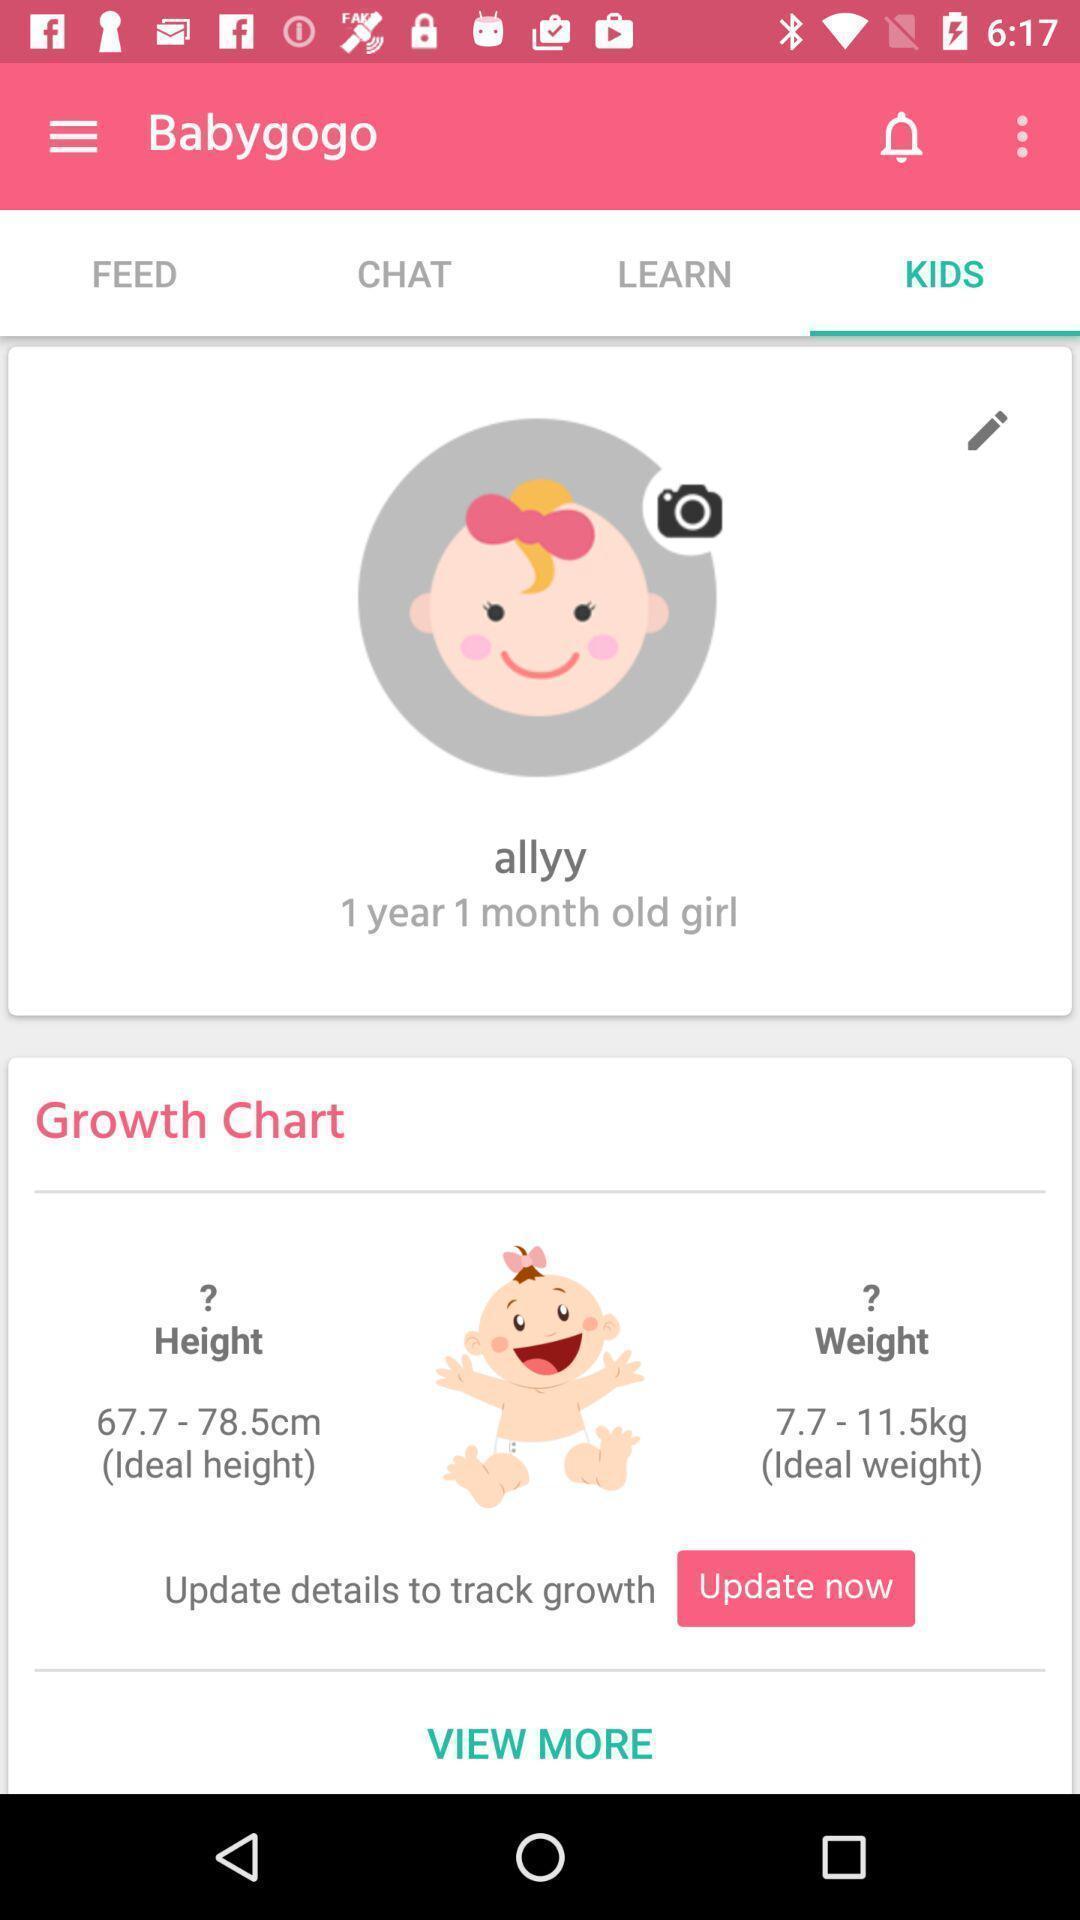What can you discern from this picture? Screen of baby care app showing kids options. 